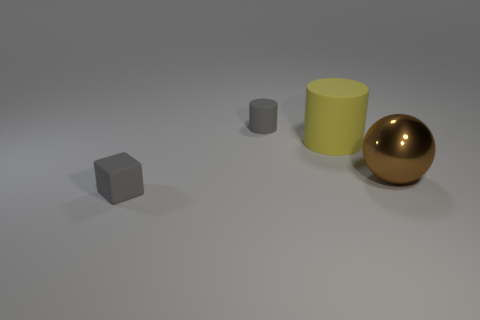What number of gray things are made of the same material as the big yellow cylinder? 2 